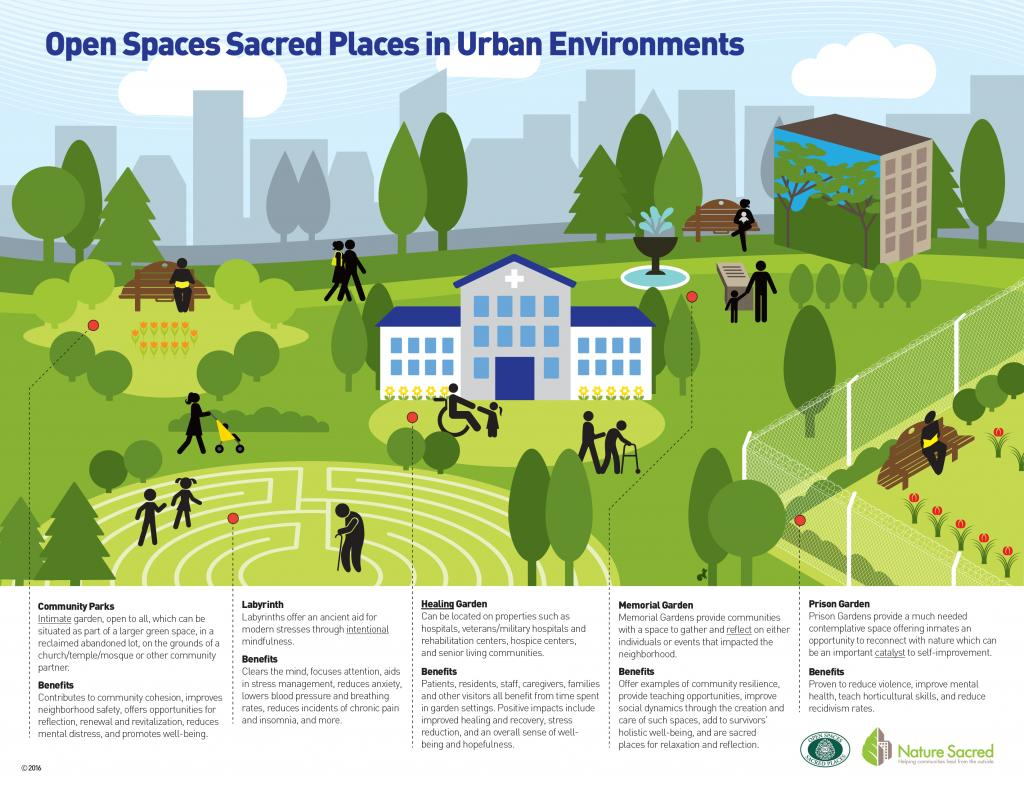Draw attention to some important aspects in this diagram. The infographic features 17 people, including infants and children. 